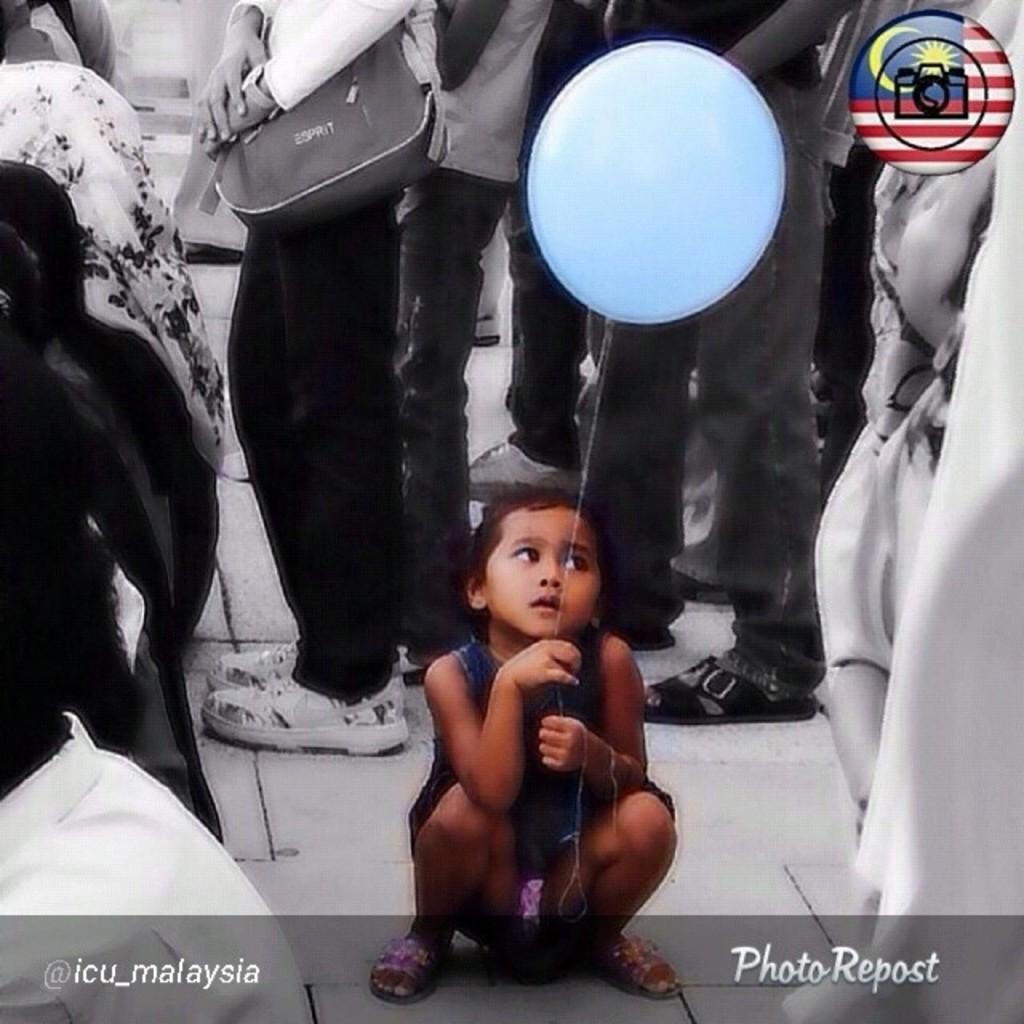What is the girl in the image doing? The girl is sitting in the image. What is the girl holding in the image? The girl is holding a balloon. What can be seen in the background of the image? There are people standing in the background of the image. What is written or depicted at the bottom of the image? There is text at the bottom of the image. How many brothers does the girl have, and what are they doing in the image? There is no information about the girl's brothers in the image, nor is there any indication of their presence or activities. 